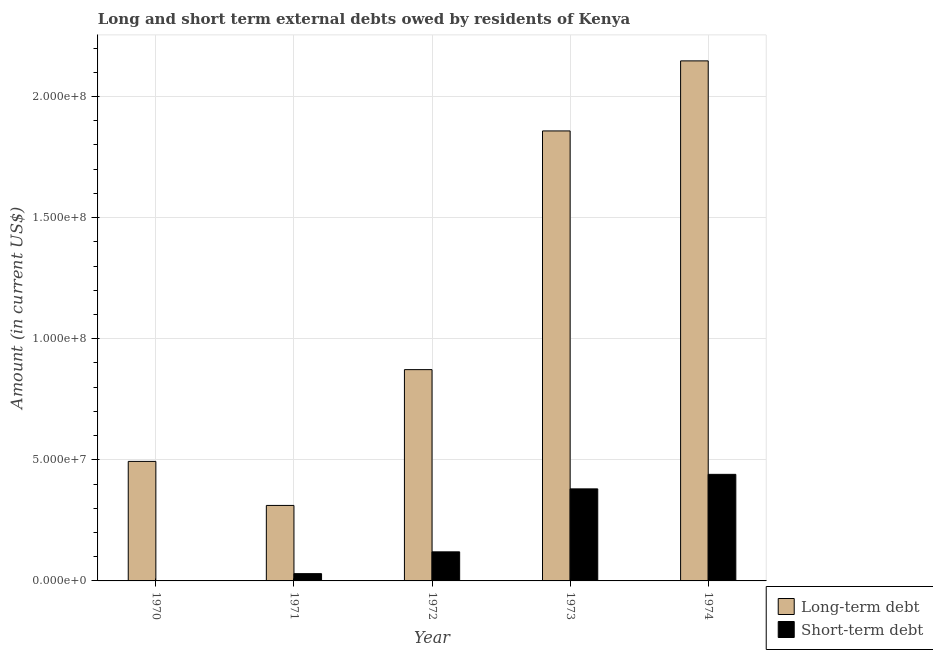Are the number of bars on each tick of the X-axis equal?
Give a very brief answer. No. How many bars are there on the 1st tick from the right?
Give a very brief answer. 2. What is the label of the 3rd group of bars from the left?
Provide a succinct answer. 1972. In how many cases, is the number of bars for a given year not equal to the number of legend labels?
Ensure brevity in your answer.  1. What is the long-term debts owed by residents in 1972?
Make the answer very short. 8.72e+07. Across all years, what is the maximum long-term debts owed by residents?
Your answer should be compact. 2.15e+08. In which year was the short-term debts owed by residents maximum?
Provide a succinct answer. 1974. What is the total long-term debts owed by residents in the graph?
Give a very brief answer. 5.68e+08. What is the difference between the long-term debts owed by residents in 1970 and that in 1973?
Provide a short and direct response. -1.36e+08. What is the difference between the short-term debts owed by residents in 1973 and the long-term debts owed by residents in 1974?
Offer a very short reply. -6.00e+06. What is the average short-term debts owed by residents per year?
Offer a very short reply. 1.94e+07. In the year 1974, what is the difference between the short-term debts owed by residents and long-term debts owed by residents?
Your answer should be very brief. 0. What is the ratio of the short-term debts owed by residents in 1972 to that in 1974?
Offer a very short reply. 0.27. What is the difference between the highest and the second highest long-term debts owed by residents?
Offer a terse response. 2.89e+07. What is the difference between the highest and the lowest short-term debts owed by residents?
Your response must be concise. 4.40e+07. In how many years, is the short-term debts owed by residents greater than the average short-term debts owed by residents taken over all years?
Offer a terse response. 2. What is the difference between two consecutive major ticks on the Y-axis?
Your answer should be very brief. 5.00e+07. Are the values on the major ticks of Y-axis written in scientific E-notation?
Give a very brief answer. Yes. Does the graph contain any zero values?
Your answer should be very brief. Yes. Where does the legend appear in the graph?
Ensure brevity in your answer.  Bottom right. How many legend labels are there?
Offer a terse response. 2. How are the legend labels stacked?
Provide a short and direct response. Vertical. What is the title of the graph?
Your answer should be very brief. Long and short term external debts owed by residents of Kenya. Does "Young" appear as one of the legend labels in the graph?
Make the answer very short. No. What is the label or title of the Y-axis?
Keep it short and to the point. Amount (in current US$). What is the Amount (in current US$) in Long-term debt in 1970?
Offer a very short reply. 4.93e+07. What is the Amount (in current US$) of Short-term debt in 1970?
Your answer should be compact. 0. What is the Amount (in current US$) in Long-term debt in 1971?
Offer a very short reply. 3.12e+07. What is the Amount (in current US$) in Short-term debt in 1971?
Provide a short and direct response. 3.00e+06. What is the Amount (in current US$) in Long-term debt in 1972?
Your answer should be compact. 8.72e+07. What is the Amount (in current US$) in Long-term debt in 1973?
Ensure brevity in your answer.  1.86e+08. What is the Amount (in current US$) of Short-term debt in 1973?
Offer a terse response. 3.80e+07. What is the Amount (in current US$) of Long-term debt in 1974?
Ensure brevity in your answer.  2.15e+08. What is the Amount (in current US$) in Short-term debt in 1974?
Offer a terse response. 4.40e+07. Across all years, what is the maximum Amount (in current US$) of Long-term debt?
Offer a terse response. 2.15e+08. Across all years, what is the maximum Amount (in current US$) in Short-term debt?
Your response must be concise. 4.40e+07. Across all years, what is the minimum Amount (in current US$) of Long-term debt?
Offer a terse response. 3.12e+07. Across all years, what is the minimum Amount (in current US$) in Short-term debt?
Provide a short and direct response. 0. What is the total Amount (in current US$) in Long-term debt in the graph?
Provide a short and direct response. 5.68e+08. What is the total Amount (in current US$) in Short-term debt in the graph?
Provide a succinct answer. 9.70e+07. What is the difference between the Amount (in current US$) in Long-term debt in 1970 and that in 1971?
Your answer should be compact. 1.82e+07. What is the difference between the Amount (in current US$) of Long-term debt in 1970 and that in 1972?
Provide a succinct answer. -3.79e+07. What is the difference between the Amount (in current US$) in Long-term debt in 1970 and that in 1973?
Give a very brief answer. -1.36e+08. What is the difference between the Amount (in current US$) in Long-term debt in 1970 and that in 1974?
Provide a short and direct response. -1.65e+08. What is the difference between the Amount (in current US$) of Long-term debt in 1971 and that in 1972?
Provide a succinct answer. -5.61e+07. What is the difference between the Amount (in current US$) in Short-term debt in 1971 and that in 1972?
Keep it short and to the point. -9.00e+06. What is the difference between the Amount (in current US$) of Long-term debt in 1971 and that in 1973?
Keep it short and to the point. -1.55e+08. What is the difference between the Amount (in current US$) in Short-term debt in 1971 and that in 1973?
Offer a very short reply. -3.50e+07. What is the difference between the Amount (in current US$) of Long-term debt in 1971 and that in 1974?
Your response must be concise. -1.84e+08. What is the difference between the Amount (in current US$) of Short-term debt in 1971 and that in 1974?
Provide a short and direct response. -4.10e+07. What is the difference between the Amount (in current US$) of Long-term debt in 1972 and that in 1973?
Offer a terse response. -9.86e+07. What is the difference between the Amount (in current US$) of Short-term debt in 1972 and that in 1973?
Keep it short and to the point. -2.60e+07. What is the difference between the Amount (in current US$) of Long-term debt in 1972 and that in 1974?
Offer a very short reply. -1.27e+08. What is the difference between the Amount (in current US$) of Short-term debt in 1972 and that in 1974?
Your answer should be very brief. -3.20e+07. What is the difference between the Amount (in current US$) of Long-term debt in 1973 and that in 1974?
Make the answer very short. -2.89e+07. What is the difference between the Amount (in current US$) of Short-term debt in 1973 and that in 1974?
Ensure brevity in your answer.  -6.00e+06. What is the difference between the Amount (in current US$) of Long-term debt in 1970 and the Amount (in current US$) of Short-term debt in 1971?
Offer a terse response. 4.63e+07. What is the difference between the Amount (in current US$) in Long-term debt in 1970 and the Amount (in current US$) in Short-term debt in 1972?
Give a very brief answer. 3.73e+07. What is the difference between the Amount (in current US$) in Long-term debt in 1970 and the Amount (in current US$) in Short-term debt in 1973?
Ensure brevity in your answer.  1.13e+07. What is the difference between the Amount (in current US$) of Long-term debt in 1970 and the Amount (in current US$) of Short-term debt in 1974?
Offer a very short reply. 5.34e+06. What is the difference between the Amount (in current US$) of Long-term debt in 1971 and the Amount (in current US$) of Short-term debt in 1972?
Ensure brevity in your answer.  1.92e+07. What is the difference between the Amount (in current US$) in Long-term debt in 1971 and the Amount (in current US$) in Short-term debt in 1973?
Keep it short and to the point. -6.83e+06. What is the difference between the Amount (in current US$) of Long-term debt in 1971 and the Amount (in current US$) of Short-term debt in 1974?
Provide a short and direct response. -1.28e+07. What is the difference between the Amount (in current US$) of Long-term debt in 1972 and the Amount (in current US$) of Short-term debt in 1973?
Offer a terse response. 4.92e+07. What is the difference between the Amount (in current US$) of Long-term debt in 1972 and the Amount (in current US$) of Short-term debt in 1974?
Your answer should be very brief. 4.32e+07. What is the difference between the Amount (in current US$) of Long-term debt in 1973 and the Amount (in current US$) of Short-term debt in 1974?
Give a very brief answer. 1.42e+08. What is the average Amount (in current US$) of Long-term debt per year?
Keep it short and to the point. 1.14e+08. What is the average Amount (in current US$) in Short-term debt per year?
Provide a succinct answer. 1.94e+07. In the year 1971, what is the difference between the Amount (in current US$) in Long-term debt and Amount (in current US$) in Short-term debt?
Your answer should be compact. 2.82e+07. In the year 1972, what is the difference between the Amount (in current US$) of Long-term debt and Amount (in current US$) of Short-term debt?
Your answer should be very brief. 7.52e+07. In the year 1973, what is the difference between the Amount (in current US$) of Long-term debt and Amount (in current US$) of Short-term debt?
Keep it short and to the point. 1.48e+08. In the year 1974, what is the difference between the Amount (in current US$) in Long-term debt and Amount (in current US$) in Short-term debt?
Provide a succinct answer. 1.71e+08. What is the ratio of the Amount (in current US$) of Long-term debt in 1970 to that in 1971?
Your response must be concise. 1.58. What is the ratio of the Amount (in current US$) of Long-term debt in 1970 to that in 1972?
Ensure brevity in your answer.  0.57. What is the ratio of the Amount (in current US$) in Long-term debt in 1970 to that in 1973?
Offer a very short reply. 0.27. What is the ratio of the Amount (in current US$) of Long-term debt in 1970 to that in 1974?
Provide a short and direct response. 0.23. What is the ratio of the Amount (in current US$) in Long-term debt in 1971 to that in 1972?
Keep it short and to the point. 0.36. What is the ratio of the Amount (in current US$) of Long-term debt in 1971 to that in 1973?
Your answer should be compact. 0.17. What is the ratio of the Amount (in current US$) of Short-term debt in 1971 to that in 1973?
Give a very brief answer. 0.08. What is the ratio of the Amount (in current US$) of Long-term debt in 1971 to that in 1974?
Offer a very short reply. 0.15. What is the ratio of the Amount (in current US$) in Short-term debt in 1971 to that in 1974?
Your answer should be compact. 0.07. What is the ratio of the Amount (in current US$) in Long-term debt in 1972 to that in 1973?
Make the answer very short. 0.47. What is the ratio of the Amount (in current US$) in Short-term debt in 1972 to that in 1973?
Your answer should be compact. 0.32. What is the ratio of the Amount (in current US$) in Long-term debt in 1972 to that in 1974?
Offer a very short reply. 0.41. What is the ratio of the Amount (in current US$) of Short-term debt in 1972 to that in 1974?
Provide a short and direct response. 0.27. What is the ratio of the Amount (in current US$) in Long-term debt in 1973 to that in 1974?
Ensure brevity in your answer.  0.87. What is the ratio of the Amount (in current US$) in Short-term debt in 1973 to that in 1974?
Ensure brevity in your answer.  0.86. What is the difference between the highest and the second highest Amount (in current US$) in Long-term debt?
Offer a terse response. 2.89e+07. What is the difference between the highest and the lowest Amount (in current US$) in Long-term debt?
Give a very brief answer. 1.84e+08. What is the difference between the highest and the lowest Amount (in current US$) of Short-term debt?
Your response must be concise. 4.40e+07. 